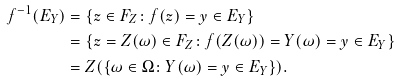Convert formula to latex. <formula><loc_0><loc_0><loc_500><loc_500>f ^ { - 1 } ( E _ { Y } ) & = \{ z \in F _ { Z } \colon f ( z ) = y \in E _ { Y } \} \\ & = \{ z = Z ( \omega ) \in F _ { Z } \colon f ( Z ( \omega ) ) = Y ( \omega ) = y \in E _ { Y } \} \\ & = Z ( \{ \omega \in \Omega \colon Y ( \omega ) = y \in E _ { Y } \} ) .</formula> 